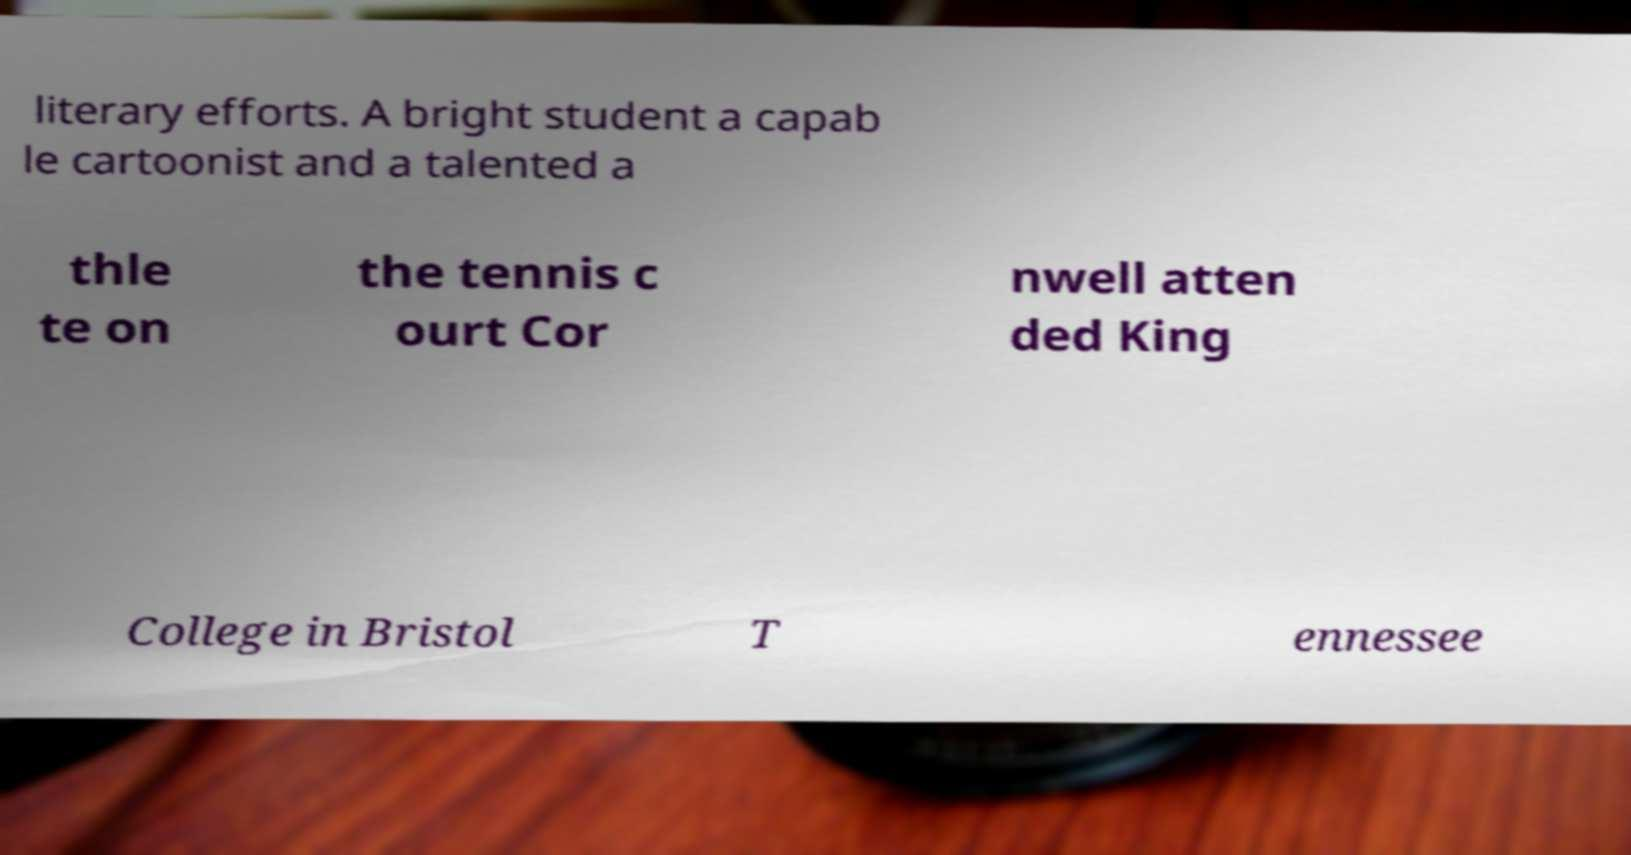Please identify and transcribe the text found in this image. literary efforts. A bright student a capab le cartoonist and a talented a thle te on the tennis c ourt Cor nwell atten ded King College in Bristol T ennessee 